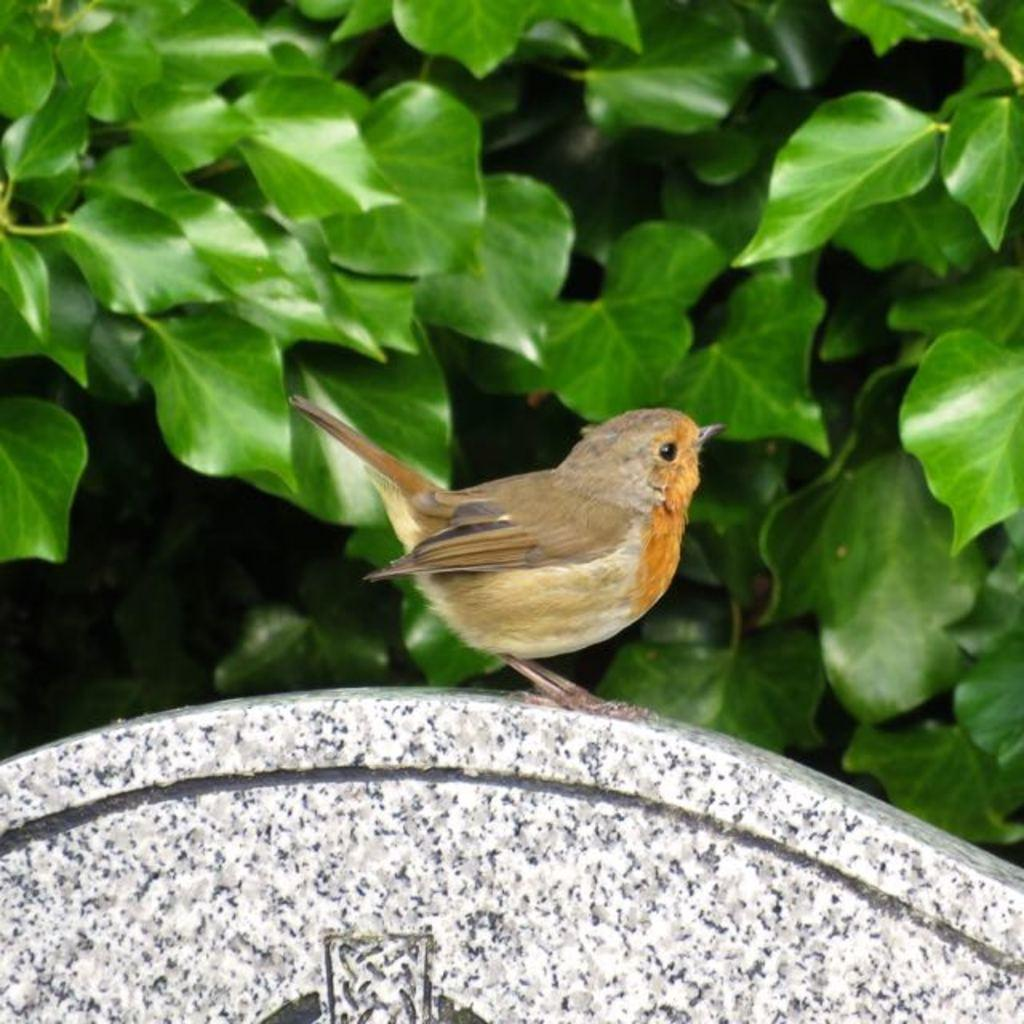What type of animal is present in the image? There is a bird in the image. What else can be seen in the image besides the bird? There are leaves in the image. Where is the river located in the image? There is no river present in the image. What type of tool is being used by the bird in the image? There is no tool, such as a wrench, present in the image. 